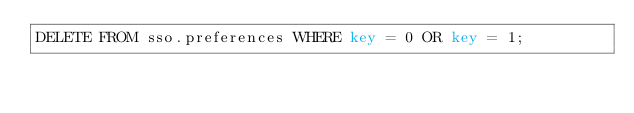<code> <loc_0><loc_0><loc_500><loc_500><_SQL_>DELETE FROM sso.preferences WHERE key = 0 OR key = 1;</code> 